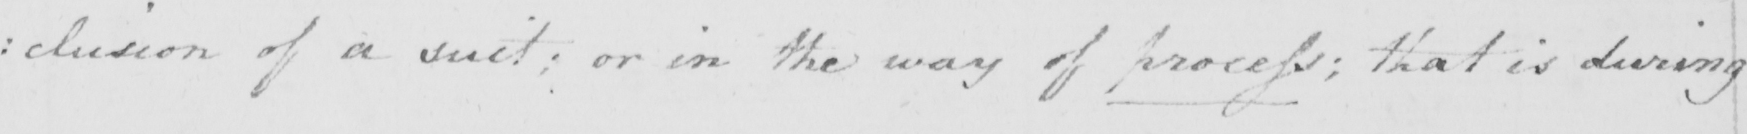Can you read and transcribe this handwriting? : clusion of a suit ; or in the way of process ; that is during 